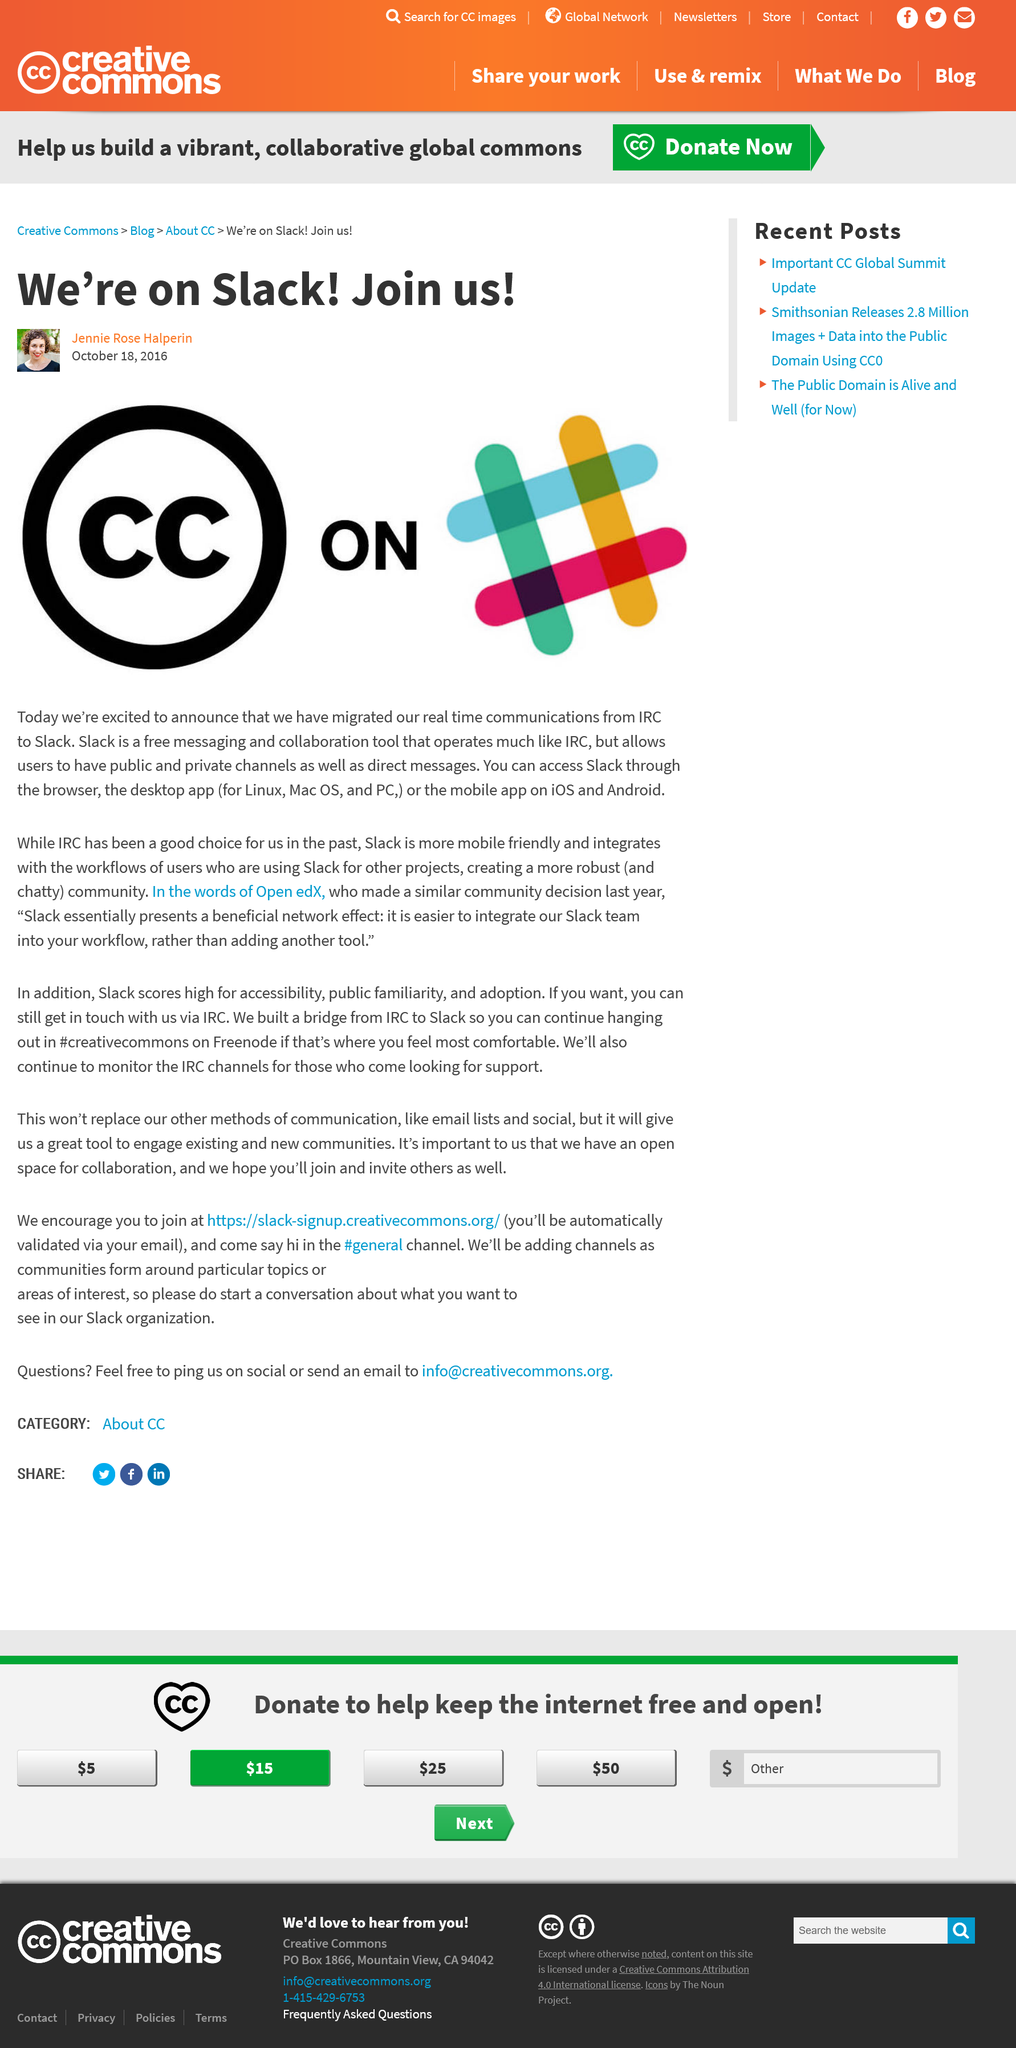Highlight a few significant elements in this photo. The current platform being used by CC is Slack. The company left behind the platform IRC. Clear Channel (CC) announced that they would be moving to Slack on October 18, 2016. 